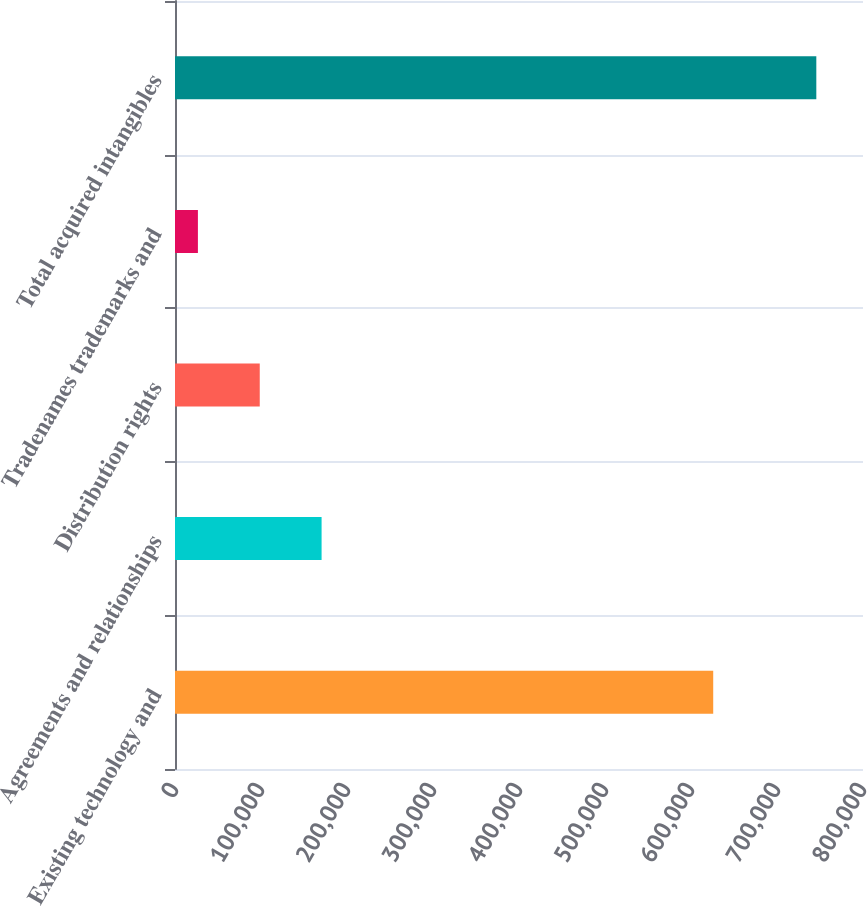Convert chart. <chart><loc_0><loc_0><loc_500><loc_500><bar_chart><fcel>Existing technology and<fcel>Agreements and relationships<fcel>Distribution rights<fcel>Tradenames trademarks and<fcel>Total acquired intangibles<nl><fcel>625832<fcel>170451<fcel>98542.5<fcel>26634<fcel>745719<nl></chart> 